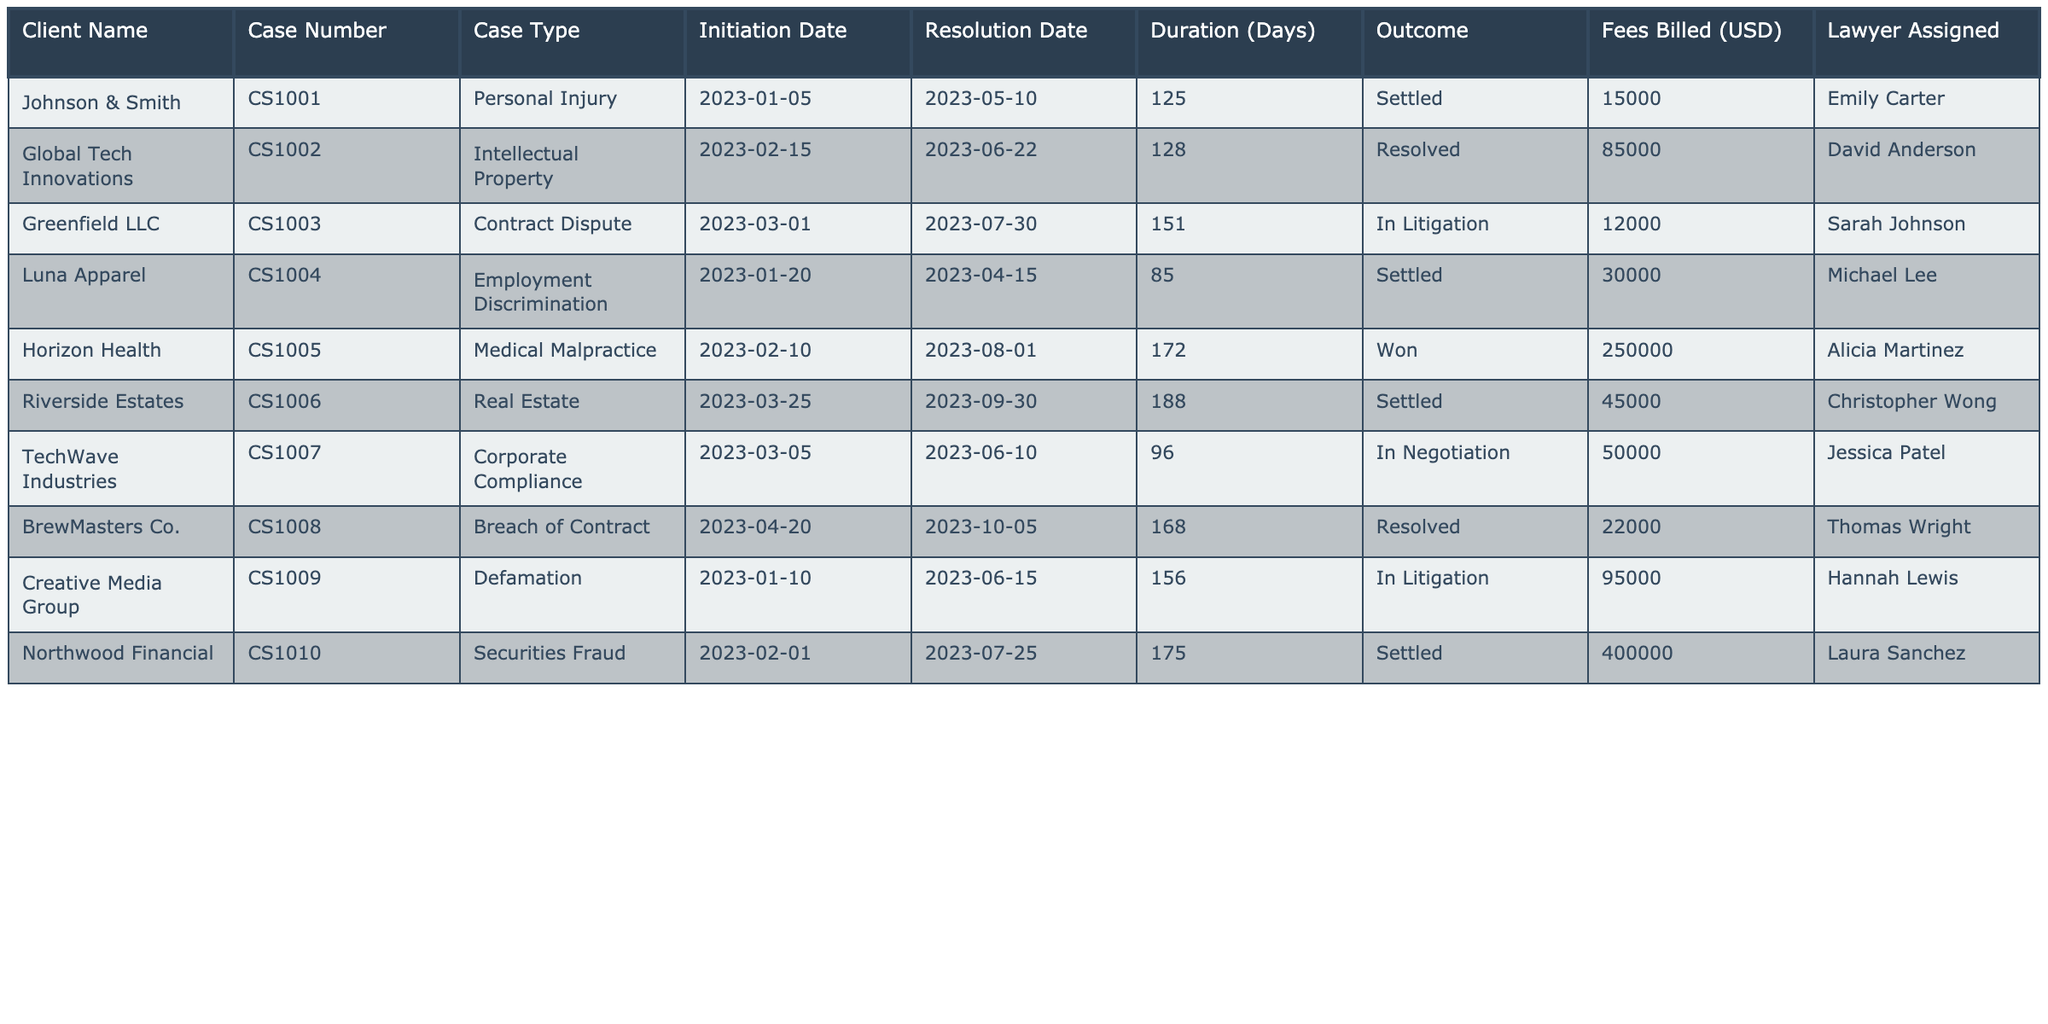What's the outcome of the case with case number CS1002? The outcome for CS1002, handled by David Anderson, is stated in the table as "Resolved."
Answer: Resolved Which client has the highest fees billed? By reviewing the fees billed in the table, Northwood Financial has the highest fees at 400,000 USD.
Answer: Northwood Financial How many cases were settled? By counting the outcome column for "Settled," we find there are five cases with this outcome in total.
Answer: 5 What is the average duration of cases that were won or settled? The durations for settled cases are 125, 85, 176, and 188 days—averaging these gives (125 + 85 + 172 + 188) / 4 = 142.5 days. The won case duration is 172 days. Adding this gives (125 + 85 + 172 + 188 + 172) / 5 = 148.4 days.
Answer: 148.4 days Is the case with the longest duration settled? The case with the longest duration is Riverside Estates, which is 188 days; however, it has an outcome of "Settled." Therefore, the answer is yes.
Answer: Yes How many clients had cases that were in litigation? Scanning through the case types, there are two clients—Greenfield LLC and Creative Media Group—whose cases are classified as "In Litigation."
Answer: 2 What was the total fees billed for cases that were resolved? The fees billed for resolved cases are: 85,000 for Global Tech Innovations and 22,000 for BrewMasters Co. Adding these gives 85,000 + 22,000 = 107,000 USD in total.
Answer: 107,000 USD Which lawyer worked on the personal injury case, and what was the duration? The personal injury case (CS1001) was handled by Emily Carter and lasted for 125 days.
Answer: Emily Carter, 125 days What is the difference in fees billed between the "Won" case and the "Settled" case with the highest fees? The "Won" case (Horizon Health) billed 250,000 USD, and the "Settled" case with the highest fees (Northwood Financial) billed 400,000 USD. The difference is 400,000 - 250,000 = 150,000 USD.
Answer: 150,000 USD Which case type had the longest duration and what was the outcome? The longest duration listed in the table is for Riverside Estates with a duration of 188 days, and the outcome for this case is "Settled."
Answer: Real Estate, Settled 